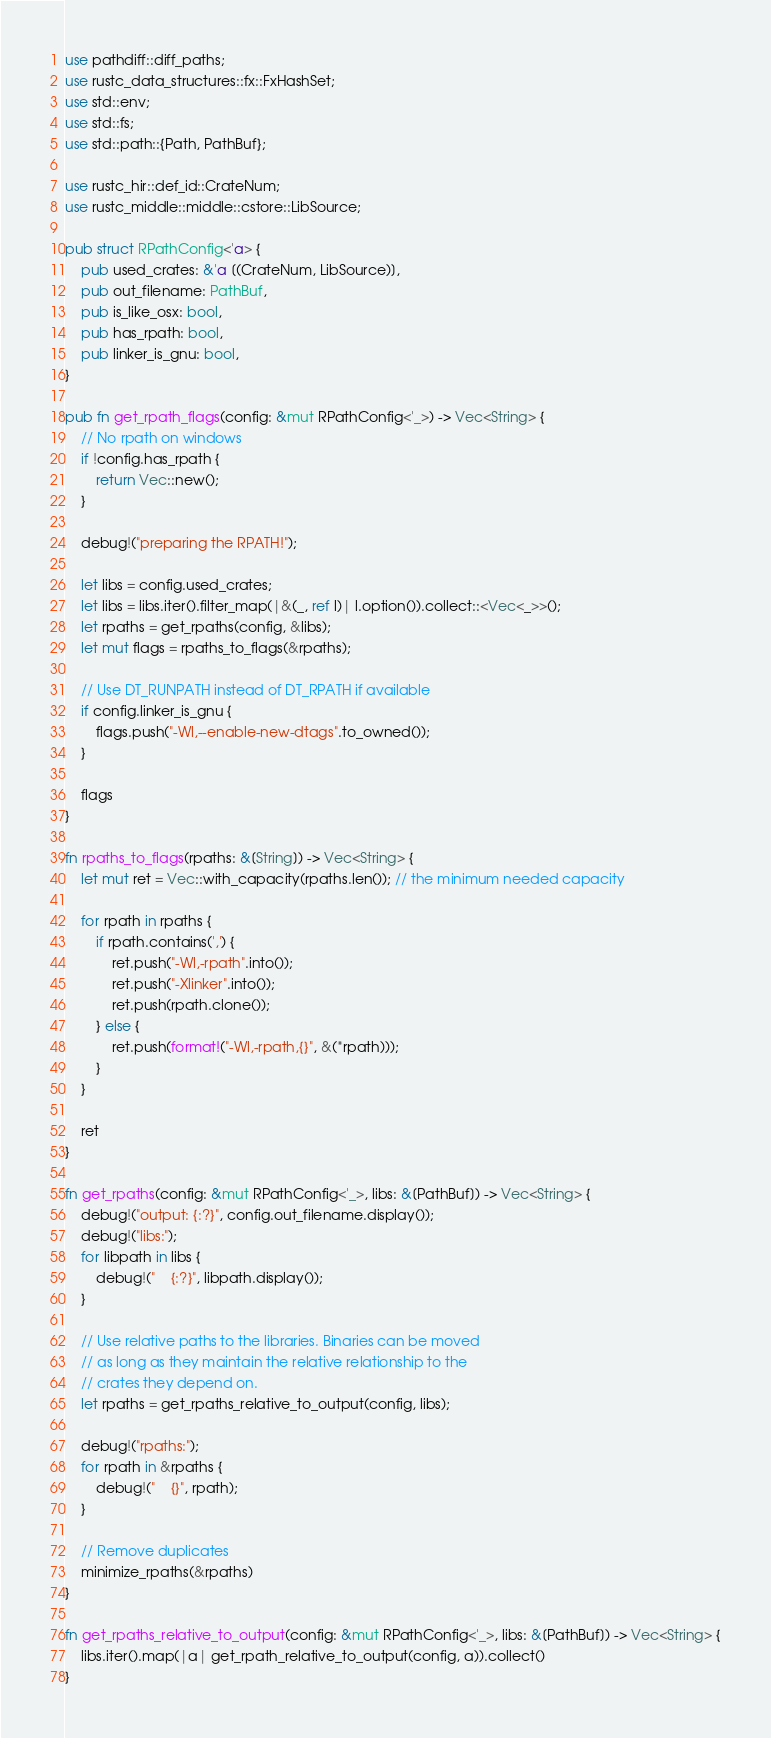Convert code to text. <code><loc_0><loc_0><loc_500><loc_500><_Rust_>use pathdiff::diff_paths;
use rustc_data_structures::fx::FxHashSet;
use std::env;
use std::fs;
use std::path::{Path, PathBuf};

use rustc_hir::def_id::CrateNum;
use rustc_middle::middle::cstore::LibSource;

pub struct RPathConfig<'a> {
    pub used_crates: &'a [(CrateNum, LibSource)],
    pub out_filename: PathBuf,
    pub is_like_osx: bool,
    pub has_rpath: bool,
    pub linker_is_gnu: bool,
}

pub fn get_rpath_flags(config: &mut RPathConfig<'_>) -> Vec<String> {
    // No rpath on windows
    if !config.has_rpath {
        return Vec::new();
    }

    debug!("preparing the RPATH!");

    let libs = config.used_crates;
    let libs = libs.iter().filter_map(|&(_, ref l)| l.option()).collect::<Vec<_>>();
    let rpaths = get_rpaths(config, &libs);
    let mut flags = rpaths_to_flags(&rpaths);

    // Use DT_RUNPATH instead of DT_RPATH if available
    if config.linker_is_gnu {
        flags.push("-Wl,--enable-new-dtags".to_owned());
    }

    flags
}

fn rpaths_to_flags(rpaths: &[String]) -> Vec<String> {
    let mut ret = Vec::with_capacity(rpaths.len()); // the minimum needed capacity

    for rpath in rpaths {
        if rpath.contains(',') {
            ret.push("-Wl,-rpath".into());
            ret.push("-Xlinker".into());
            ret.push(rpath.clone());
        } else {
            ret.push(format!("-Wl,-rpath,{}", &(*rpath)));
        }
    }

    ret
}

fn get_rpaths(config: &mut RPathConfig<'_>, libs: &[PathBuf]) -> Vec<String> {
    debug!("output: {:?}", config.out_filename.display());
    debug!("libs:");
    for libpath in libs {
        debug!("    {:?}", libpath.display());
    }

    // Use relative paths to the libraries. Binaries can be moved
    // as long as they maintain the relative relationship to the
    // crates they depend on.
    let rpaths = get_rpaths_relative_to_output(config, libs);

    debug!("rpaths:");
    for rpath in &rpaths {
        debug!("    {}", rpath);
    }

    // Remove duplicates
    minimize_rpaths(&rpaths)
}

fn get_rpaths_relative_to_output(config: &mut RPathConfig<'_>, libs: &[PathBuf]) -> Vec<String> {
    libs.iter().map(|a| get_rpath_relative_to_output(config, a)).collect()
}
</code> 